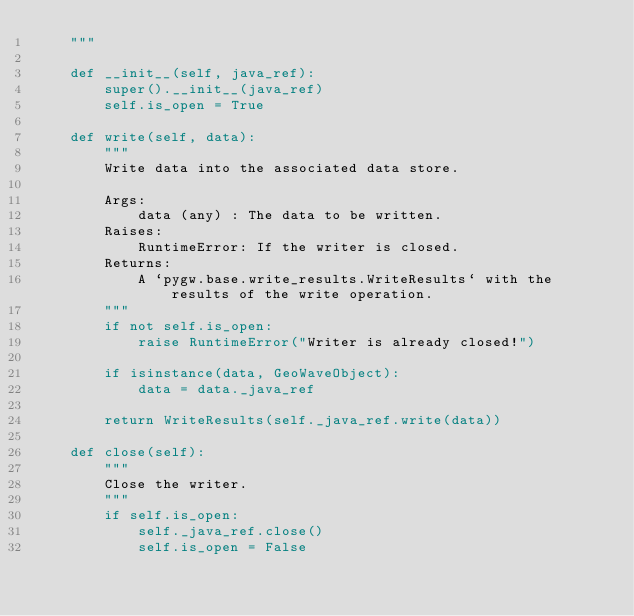Convert code to text. <code><loc_0><loc_0><loc_500><loc_500><_Python_>    """

    def __init__(self, java_ref):
        super().__init__(java_ref)
        self.is_open = True

    def write(self, data):
        """
        Write data into the associated data store.

        Args:
            data (any) : The data to be written.
        Raises:
            RuntimeError: If the writer is closed.
        Returns:
            A `pygw.base.write_results.WriteResults` with the results of the write operation.
        """
        if not self.is_open:
            raise RuntimeError("Writer is already closed!")

        if isinstance(data, GeoWaveObject):
            data = data._java_ref

        return WriteResults(self._java_ref.write(data))

    def close(self):
        """
        Close the writer.
        """
        if self.is_open:
            self._java_ref.close()
            self.is_open = False
</code> 